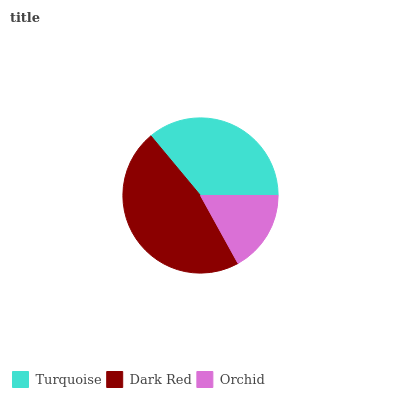Is Orchid the minimum?
Answer yes or no. Yes. Is Dark Red the maximum?
Answer yes or no. Yes. Is Dark Red the minimum?
Answer yes or no. No. Is Orchid the maximum?
Answer yes or no. No. Is Dark Red greater than Orchid?
Answer yes or no. Yes. Is Orchid less than Dark Red?
Answer yes or no. Yes. Is Orchid greater than Dark Red?
Answer yes or no. No. Is Dark Red less than Orchid?
Answer yes or no. No. Is Turquoise the high median?
Answer yes or no. Yes. Is Turquoise the low median?
Answer yes or no. Yes. Is Dark Red the high median?
Answer yes or no. No. Is Orchid the low median?
Answer yes or no. No. 